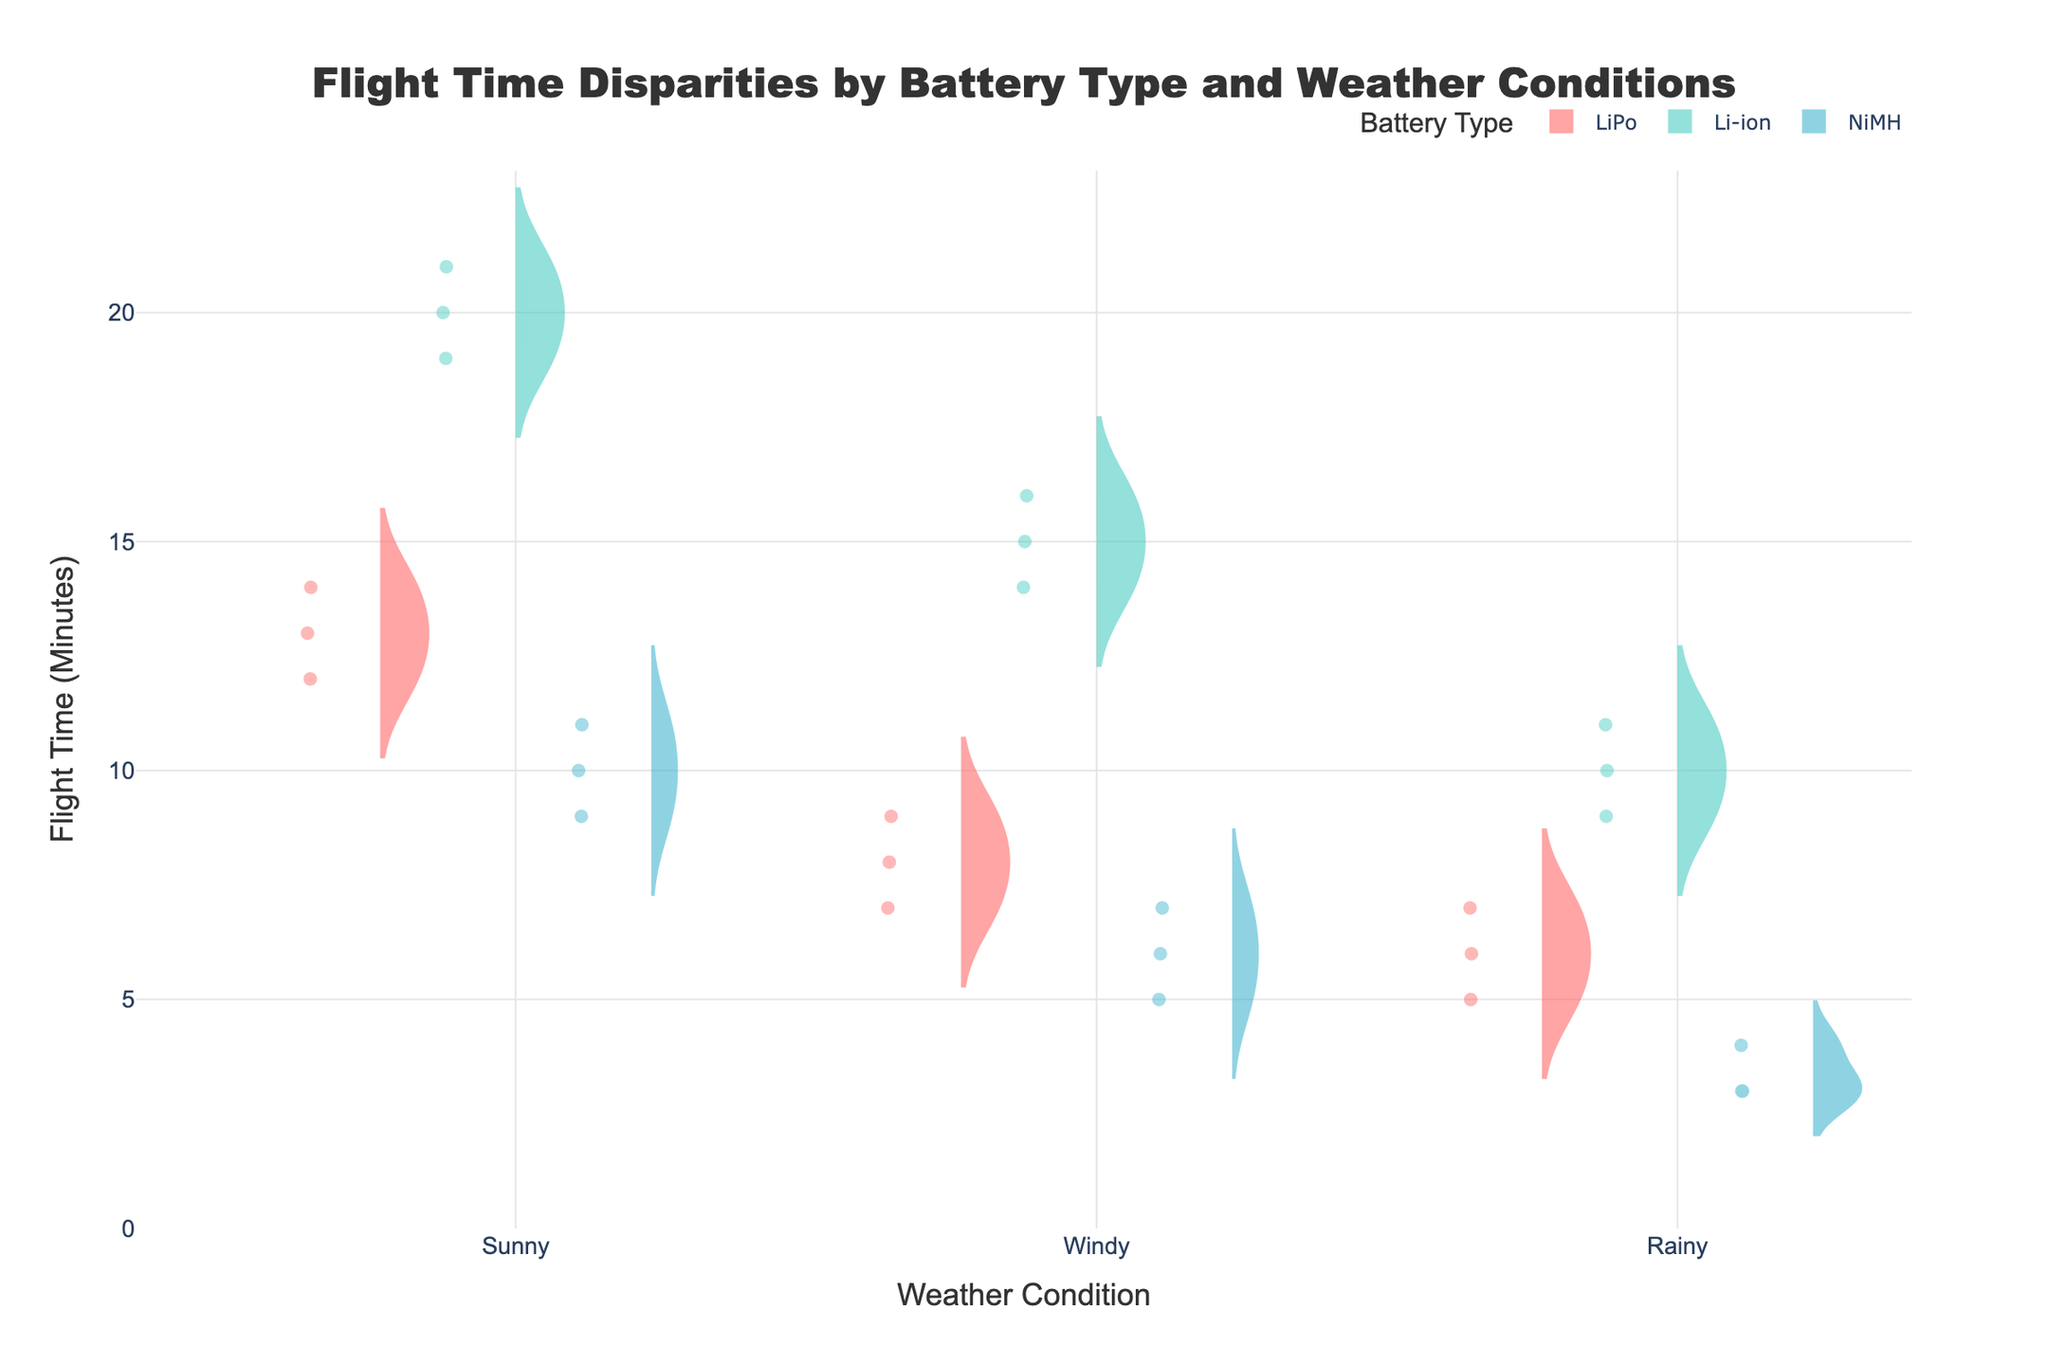Which battery type has the shortest median flight time in sunny weather? To determine the shortest median flight time in sunny weather, look at the box plot overlay for each battery type under sunny weather conditions. Identify the median line within the box plot and compare across the three battery types.
Answer: NiMH How does the flight time variability of LiPo batteries compare between windy and rainy conditions? Compare the width of the violin plots and the range of the data points for LiPo batteries under windy and rainy conditions. The wider the violin plot and the more dispersed the data points, the higher the variability.
Answer: Windy conditions have more variability What's the mean flight time for Li-ion batteries in sunny weather based on the figure? Locate the mean line within the box plot overlay for Li-ion batteries under sunny weather conditions. This line represents the mean flight time.
Answer: 20 minutes Which weather condition generally results in the longest flight times for all battery types? Compare the flight times across different weather conditions (Sunny, Windy, Rainy) by looking for the weather condition with the highest values in the violin plots for all battery types.
Answer: Sunny Are there any outliers in the flight times of NiMH batteries in rainy weather? Outliers in box plots are typically indicated by individual points that lie beyond the whiskers (the ends of the plot lines). Check the NiMH battery plot under rainy conditions for any such points.
Answer: No How does the median flight time of LiPo batteries in sunny weather compare to rainy weather? Compare the median line within the box plot overlay for LiPo batteries between sunny and rainy weather conditions to see which one is higher and by how much.
Answer: The median flight time is higher in sunny weather What is the range of flight times for Li-ion batteries in windy conditions based on the box plot overlay? Calculate the range by subtracting the minimum value (bottom whisker) from the maximum value (top whisker) in the box plot for Li-ion batteries under windy conditions.
Answer: 14 to 16 minutes Which battery type exhibits the highest variability in flight times under rainy conditions? Compare the width and dispersion of the violin plots for each battery type under rainy conditions. The battery type with the widest plot and most spread out data points exhibits the highest variability.
Answer: NiMH Which battery type consistently has the highest flight times across all weather conditions? Examine the highest data points and the median lines within the box plots for each battery type across all weather conditions. Identify which battery type usually records the highest values.
Answer: Li-ion 